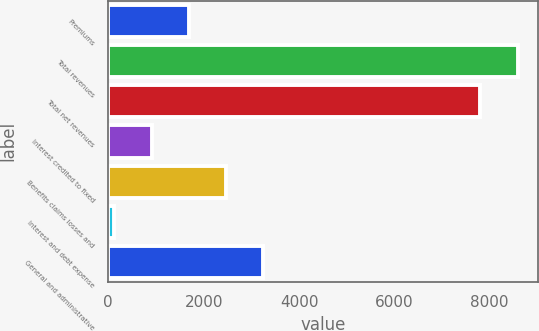Convert chart to OTSL. <chart><loc_0><loc_0><loc_500><loc_500><bar_chart><fcel>Premiums<fcel>Total revenues<fcel>Total net revenues<fcel>Interest credited to fixed<fcel>Benefits claims losses and<fcel>Interest and debt expense<fcel>General and administrative<nl><fcel>1690.8<fcel>8586.9<fcel>7805<fcel>908.9<fcel>2472.7<fcel>127<fcel>3254.6<nl></chart> 